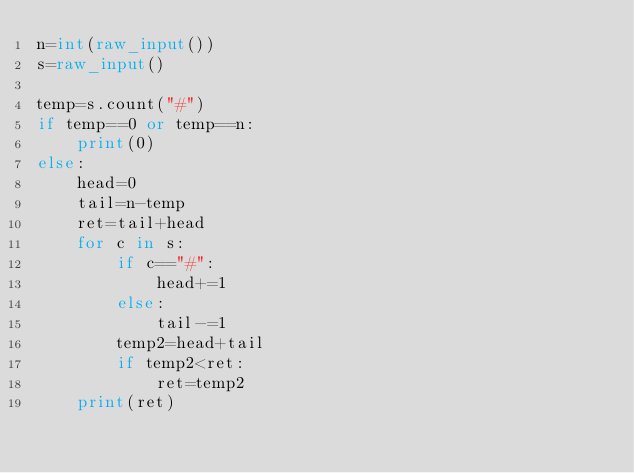<code> <loc_0><loc_0><loc_500><loc_500><_Python_>n=int(raw_input())
s=raw_input()

temp=s.count("#")
if temp==0 or temp==n:
    print(0)
else:
    head=0
    tail=n-temp
    ret=tail+head
    for c in s:
        if c=="#":
            head+=1
        else:
            tail-=1
        temp2=head+tail
        if temp2<ret:
            ret=temp2
    print(ret)
</code> 